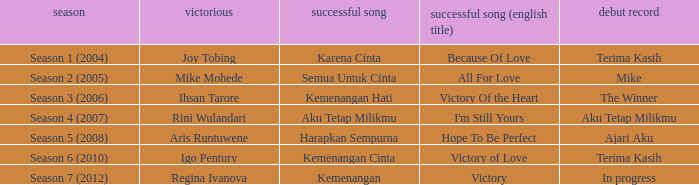Which album debuted in season 2 (2005)? Mike. 